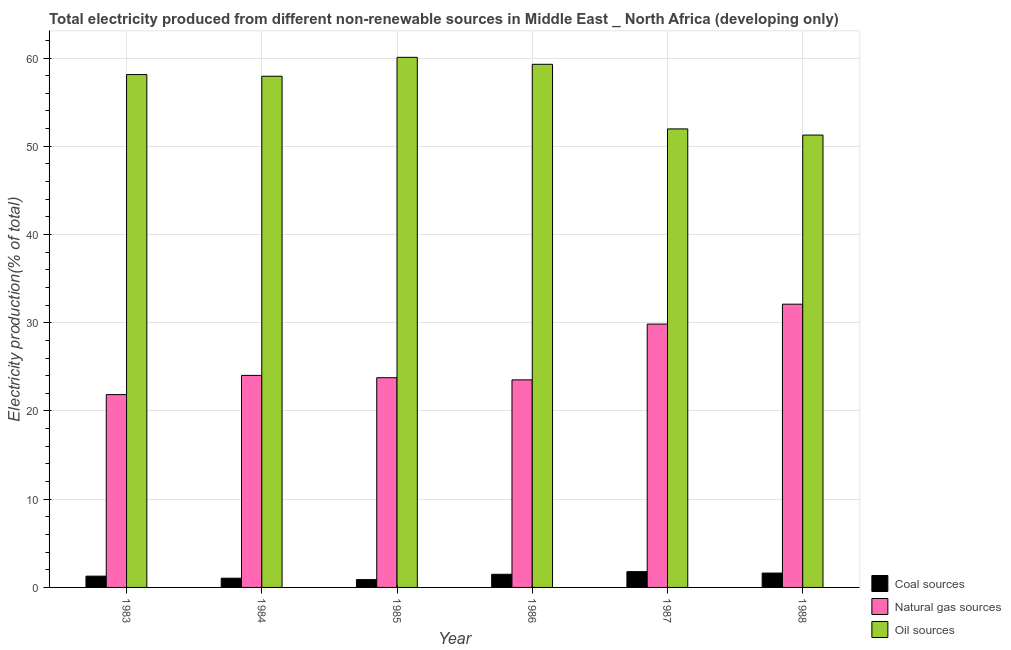How many different coloured bars are there?
Your response must be concise. 3. How many groups of bars are there?
Your answer should be compact. 6. What is the label of the 6th group of bars from the left?
Ensure brevity in your answer.  1988. In how many cases, is the number of bars for a given year not equal to the number of legend labels?
Provide a succinct answer. 0. What is the percentage of electricity produced by oil sources in 1987?
Your answer should be compact. 51.96. Across all years, what is the maximum percentage of electricity produced by oil sources?
Offer a very short reply. 60.08. Across all years, what is the minimum percentage of electricity produced by natural gas?
Your answer should be very brief. 21.85. In which year was the percentage of electricity produced by coal maximum?
Offer a terse response. 1987. In which year was the percentage of electricity produced by coal minimum?
Ensure brevity in your answer.  1985. What is the total percentage of electricity produced by oil sources in the graph?
Your answer should be very brief. 338.65. What is the difference between the percentage of electricity produced by oil sources in 1984 and that in 1986?
Provide a succinct answer. -1.35. What is the difference between the percentage of electricity produced by coal in 1988 and the percentage of electricity produced by oil sources in 1984?
Offer a very short reply. 0.58. What is the average percentage of electricity produced by coal per year?
Provide a succinct answer. 1.35. What is the ratio of the percentage of electricity produced by coal in 1983 to that in 1987?
Offer a terse response. 0.71. What is the difference between the highest and the second highest percentage of electricity produced by coal?
Your answer should be compact. 0.16. What is the difference between the highest and the lowest percentage of electricity produced by natural gas?
Provide a short and direct response. 10.25. In how many years, is the percentage of electricity produced by natural gas greater than the average percentage of electricity produced by natural gas taken over all years?
Keep it short and to the point. 2. Is the sum of the percentage of electricity produced by coal in 1983 and 1986 greater than the maximum percentage of electricity produced by natural gas across all years?
Offer a terse response. Yes. What does the 2nd bar from the left in 1988 represents?
Offer a very short reply. Natural gas sources. What does the 3rd bar from the right in 1985 represents?
Provide a short and direct response. Coal sources. Is it the case that in every year, the sum of the percentage of electricity produced by coal and percentage of electricity produced by natural gas is greater than the percentage of electricity produced by oil sources?
Provide a succinct answer. No. Are all the bars in the graph horizontal?
Your response must be concise. No. How many years are there in the graph?
Your answer should be compact. 6. What is the difference between two consecutive major ticks on the Y-axis?
Offer a terse response. 10. Does the graph contain any zero values?
Keep it short and to the point. No. Does the graph contain grids?
Offer a terse response. Yes. Where does the legend appear in the graph?
Your response must be concise. Bottom right. How many legend labels are there?
Keep it short and to the point. 3. What is the title of the graph?
Provide a short and direct response. Total electricity produced from different non-renewable sources in Middle East _ North Africa (developing only). What is the Electricity production(% of total) of Coal sources in 1983?
Your answer should be compact. 1.28. What is the Electricity production(% of total) of Natural gas sources in 1983?
Your response must be concise. 21.85. What is the Electricity production(% of total) of Oil sources in 1983?
Your response must be concise. 58.12. What is the Electricity production(% of total) of Coal sources in 1984?
Provide a short and direct response. 1.05. What is the Electricity production(% of total) of Natural gas sources in 1984?
Offer a terse response. 24.03. What is the Electricity production(% of total) of Oil sources in 1984?
Give a very brief answer. 57.93. What is the Electricity production(% of total) of Coal sources in 1985?
Offer a very short reply. 0.89. What is the Electricity production(% of total) of Natural gas sources in 1985?
Offer a terse response. 23.77. What is the Electricity production(% of total) of Oil sources in 1985?
Ensure brevity in your answer.  60.08. What is the Electricity production(% of total) in Coal sources in 1986?
Your answer should be compact. 1.49. What is the Electricity production(% of total) in Natural gas sources in 1986?
Keep it short and to the point. 23.52. What is the Electricity production(% of total) of Oil sources in 1986?
Your answer should be very brief. 59.29. What is the Electricity production(% of total) in Coal sources in 1987?
Your answer should be very brief. 1.79. What is the Electricity production(% of total) in Natural gas sources in 1987?
Your response must be concise. 29.85. What is the Electricity production(% of total) of Oil sources in 1987?
Provide a succinct answer. 51.96. What is the Electricity production(% of total) of Coal sources in 1988?
Offer a terse response. 1.63. What is the Electricity production(% of total) in Natural gas sources in 1988?
Offer a terse response. 32.1. What is the Electricity production(% of total) in Oil sources in 1988?
Ensure brevity in your answer.  51.27. Across all years, what is the maximum Electricity production(% of total) in Coal sources?
Keep it short and to the point. 1.79. Across all years, what is the maximum Electricity production(% of total) of Natural gas sources?
Your answer should be compact. 32.1. Across all years, what is the maximum Electricity production(% of total) in Oil sources?
Provide a succinct answer. 60.08. Across all years, what is the minimum Electricity production(% of total) of Coal sources?
Provide a succinct answer. 0.89. Across all years, what is the minimum Electricity production(% of total) in Natural gas sources?
Offer a very short reply. 21.85. Across all years, what is the minimum Electricity production(% of total) of Oil sources?
Keep it short and to the point. 51.27. What is the total Electricity production(% of total) of Coal sources in the graph?
Your answer should be very brief. 8.12. What is the total Electricity production(% of total) in Natural gas sources in the graph?
Your answer should be very brief. 155.12. What is the total Electricity production(% of total) in Oil sources in the graph?
Offer a very short reply. 338.65. What is the difference between the Electricity production(% of total) in Coal sources in 1983 and that in 1984?
Offer a very short reply. 0.23. What is the difference between the Electricity production(% of total) of Natural gas sources in 1983 and that in 1984?
Your response must be concise. -2.18. What is the difference between the Electricity production(% of total) in Oil sources in 1983 and that in 1984?
Offer a terse response. 0.19. What is the difference between the Electricity production(% of total) in Coal sources in 1983 and that in 1985?
Your answer should be very brief. 0.39. What is the difference between the Electricity production(% of total) in Natural gas sources in 1983 and that in 1985?
Ensure brevity in your answer.  -1.92. What is the difference between the Electricity production(% of total) in Oil sources in 1983 and that in 1985?
Offer a very short reply. -1.95. What is the difference between the Electricity production(% of total) of Coal sources in 1983 and that in 1986?
Keep it short and to the point. -0.21. What is the difference between the Electricity production(% of total) in Natural gas sources in 1983 and that in 1986?
Offer a very short reply. -1.67. What is the difference between the Electricity production(% of total) of Oil sources in 1983 and that in 1986?
Your response must be concise. -1.16. What is the difference between the Electricity production(% of total) of Coal sources in 1983 and that in 1987?
Give a very brief answer. -0.51. What is the difference between the Electricity production(% of total) in Natural gas sources in 1983 and that in 1987?
Provide a short and direct response. -7.99. What is the difference between the Electricity production(% of total) of Oil sources in 1983 and that in 1987?
Your response must be concise. 6.16. What is the difference between the Electricity production(% of total) in Coal sources in 1983 and that in 1988?
Give a very brief answer. -0.35. What is the difference between the Electricity production(% of total) of Natural gas sources in 1983 and that in 1988?
Make the answer very short. -10.25. What is the difference between the Electricity production(% of total) in Oil sources in 1983 and that in 1988?
Offer a very short reply. 6.86. What is the difference between the Electricity production(% of total) of Coal sources in 1984 and that in 1985?
Your answer should be very brief. 0.16. What is the difference between the Electricity production(% of total) of Natural gas sources in 1984 and that in 1985?
Ensure brevity in your answer.  0.26. What is the difference between the Electricity production(% of total) of Oil sources in 1984 and that in 1985?
Offer a terse response. -2.14. What is the difference between the Electricity production(% of total) in Coal sources in 1984 and that in 1986?
Your answer should be very brief. -0.44. What is the difference between the Electricity production(% of total) in Natural gas sources in 1984 and that in 1986?
Offer a terse response. 0.51. What is the difference between the Electricity production(% of total) of Oil sources in 1984 and that in 1986?
Provide a succinct answer. -1.35. What is the difference between the Electricity production(% of total) in Coal sources in 1984 and that in 1987?
Offer a very short reply. -0.74. What is the difference between the Electricity production(% of total) of Natural gas sources in 1984 and that in 1987?
Ensure brevity in your answer.  -5.82. What is the difference between the Electricity production(% of total) of Oil sources in 1984 and that in 1987?
Provide a short and direct response. 5.97. What is the difference between the Electricity production(% of total) in Coal sources in 1984 and that in 1988?
Keep it short and to the point. -0.58. What is the difference between the Electricity production(% of total) in Natural gas sources in 1984 and that in 1988?
Provide a succinct answer. -8.07. What is the difference between the Electricity production(% of total) of Oil sources in 1984 and that in 1988?
Your response must be concise. 6.67. What is the difference between the Electricity production(% of total) in Coal sources in 1985 and that in 1986?
Your response must be concise. -0.6. What is the difference between the Electricity production(% of total) of Natural gas sources in 1985 and that in 1986?
Your answer should be compact. 0.24. What is the difference between the Electricity production(% of total) of Oil sources in 1985 and that in 1986?
Give a very brief answer. 0.79. What is the difference between the Electricity production(% of total) of Coal sources in 1985 and that in 1987?
Make the answer very short. -0.9. What is the difference between the Electricity production(% of total) of Natural gas sources in 1985 and that in 1987?
Your answer should be very brief. -6.08. What is the difference between the Electricity production(% of total) in Oil sources in 1985 and that in 1987?
Your answer should be very brief. 8.11. What is the difference between the Electricity production(% of total) of Coal sources in 1985 and that in 1988?
Ensure brevity in your answer.  -0.74. What is the difference between the Electricity production(% of total) of Natural gas sources in 1985 and that in 1988?
Give a very brief answer. -8.33. What is the difference between the Electricity production(% of total) of Oil sources in 1985 and that in 1988?
Make the answer very short. 8.81. What is the difference between the Electricity production(% of total) of Coal sources in 1986 and that in 1987?
Offer a very short reply. -0.3. What is the difference between the Electricity production(% of total) of Natural gas sources in 1986 and that in 1987?
Your answer should be very brief. -6.32. What is the difference between the Electricity production(% of total) of Oil sources in 1986 and that in 1987?
Provide a succinct answer. 7.32. What is the difference between the Electricity production(% of total) of Coal sources in 1986 and that in 1988?
Your answer should be very brief. -0.14. What is the difference between the Electricity production(% of total) in Natural gas sources in 1986 and that in 1988?
Your answer should be compact. -8.58. What is the difference between the Electricity production(% of total) of Oil sources in 1986 and that in 1988?
Keep it short and to the point. 8.02. What is the difference between the Electricity production(% of total) in Coal sources in 1987 and that in 1988?
Make the answer very short. 0.16. What is the difference between the Electricity production(% of total) in Natural gas sources in 1987 and that in 1988?
Keep it short and to the point. -2.26. What is the difference between the Electricity production(% of total) in Oil sources in 1987 and that in 1988?
Keep it short and to the point. 0.7. What is the difference between the Electricity production(% of total) of Coal sources in 1983 and the Electricity production(% of total) of Natural gas sources in 1984?
Provide a succinct answer. -22.75. What is the difference between the Electricity production(% of total) of Coal sources in 1983 and the Electricity production(% of total) of Oil sources in 1984?
Ensure brevity in your answer.  -56.66. What is the difference between the Electricity production(% of total) in Natural gas sources in 1983 and the Electricity production(% of total) in Oil sources in 1984?
Offer a very short reply. -36.08. What is the difference between the Electricity production(% of total) in Coal sources in 1983 and the Electricity production(% of total) in Natural gas sources in 1985?
Keep it short and to the point. -22.49. What is the difference between the Electricity production(% of total) of Coal sources in 1983 and the Electricity production(% of total) of Oil sources in 1985?
Your answer should be very brief. -58.8. What is the difference between the Electricity production(% of total) in Natural gas sources in 1983 and the Electricity production(% of total) in Oil sources in 1985?
Keep it short and to the point. -38.22. What is the difference between the Electricity production(% of total) in Coal sources in 1983 and the Electricity production(% of total) in Natural gas sources in 1986?
Your answer should be very brief. -22.25. What is the difference between the Electricity production(% of total) in Coal sources in 1983 and the Electricity production(% of total) in Oil sources in 1986?
Give a very brief answer. -58.01. What is the difference between the Electricity production(% of total) of Natural gas sources in 1983 and the Electricity production(% of total) of Oil sources in 1986?
Your answer should be compact. -37.43. What is the difference between the Electricity production(% of total) of Coal sources in 1983 and the Electricity production(% of total) of Natural gas sources in 1987?
Give a very brief answer. -28.57. What is the difference between the Electricity production(% of total) of Coal sources in 1983 and the Electricity production(% of total) of Oil sources in 1987?
Offer a very short reply. -50.69. What is the difference between the Electricity production(% of total) in Natural gas sources in 1983 and the Electricity production(% of total) in Oil sources in 1987?
Give a very brief answer. -30.11. What is the difference between the Electricity production(% of total) of Coal sources in 1983 and the Electricity production(% of total) of Natural gas sources in 1988?
Keep it short and to the point. -30.82. What is the difference between the Electricity production(% of total) of Coal sources in 1983 and the Electricity production(% of total) of Oil sources in 1988?
Provide a short and direct response. -49.99. What is the difference between the Electricity production(% of total) in Natural gas sources in 1983 and the Electricity production(% of total) in Oil sources in 1988?
Keep it short and to the point. -29.41. What is the difference between the Electricity production(% of total) of Coal sources in 1984 and the Electricity production(% of total) of Natural gas sources in 1985?
Give a very brief answer. -22.72. What is the difference between the Electricity production(% of total) of Coal sources in 1984 and the Electricity production(% of total) of Oil sources in 1985?
Provide a short and direct response. -59.03. What is the difference between the Electricity production(% of total) in Natural gas sources in 1984 and the Electricity production(% of total) in Oil sources in 1985?
Your response must be concise. -36.05. What is the difference between the Electricity production(% of total) in Coal sources in 1984 and the Electricity production(% of total) in Natural gas sources in 1986?
Keep it short and to the point. -22.48. What is the difference between the Electricity production(% of total) of Coal sources in 1984 and the Electricity production(% of total) of Oil sources in 1986?
Offer a very short reply. -58.24. What is the difference between the Electricity production(% of total) of Natural gas sources in 1984 and the Electricity production(% of total) of Oil sources in 1986?
Make the answer very short. -35.26. What is the difference between the Electricity production(% of total) of Coal sources in 1984 and the Electricity production(% of total) of Natural gas sources in 1987?
Your response must be concise. -28.8. What is the difference between the Electricity production(% of total) of Coal sources in 1984 and the Electricity production(% of total) of Oil sources in 1987?
Offer a terse response. -50.92. What is the difference between the Electricity production(% of total) of Natural gas sources in 1984 and the Electricity production(% of total) of Oil sources in 1987?
Keep it short and to the point. -27.93. What is the difference between the Electricity production(% of total) of Coal sources in 1984 and the Electricity production(% of total) of Natural gas sources in 1988?
Your response must be concise. -31.05. What is the difference between the Electricity production(% of total) in Coal sources in 1984 and the Electricity production(% of total) in Oil sources in 1988?
Make the answer very short. -50.22. What is the difference between the Electricity production(% of total) in Natural gas sources in 1984 and the Electricity production(% of total) in Oil sources in 1988?
Keep it short and to the point. -27.24. What is the difference between the Electricity production(% of total) of Coal sources in 1985 and the Electricity production(% of total) of Natural gas sources in 1986?
Offer a very short reply. -22.64. What is the difference between the Electricity production(% of total) in Coal sources in 1985 and the Electricity production(% of total) in Oil sources in 1986?
Provide a succinct answer. -58.4. What is the difference between the Electricity production(% of total) of Natural gas sources in 1985 and the Electricity production(% of total) of Oil sources in 1986?
Your answer should be compact. -35.52. What is the difference between the Electricity production(% of total) of Coal sources in 1985 and the Electricity production(% of total) of Natural gas sources in 1987?
Keep it short and to the point. -28.96. What is the difference between the Electricity production(% of total) of Coal sources in 1985 and the Electricity production(% of total) of Oil sources in 1987?
Your answer should be very brief. -51.08. What is the difference between the Electricity production(% of total) of Natural gas sources in 1985 and the Electricity production(% of total) of Oil sources in 1987?
Ensure brevity in your answer.  -28.2. What is the difference between the Electricity production(% of total) in Coal sources in 1985 and the Electricity production(% of total) in Natural gas sources in 1988?
Your answer should be compact. -31.21. What is the difference between the Electricity production(% of total) of Coal sources in 1985 and the Electricity production(% of total) of Oil sources in 1988?
Provide a short and direct response. -50.38. What is the difference between the Electricity production(% of total) in Natural gas sources in 1985 and the Electricity production(% of total) in Oil sources in 1988?
Make the answer very short. -27.5. What is the difference between the Electricity production(% of total) in Coal sources in 1986 and the Electricity production(% of total) in Natural gas sources in 1987?
Keep it short and to the point. -28.35. What is the difference between the Electricity production(% of total) of Coal sources in 1986 and the Electricity production(% of total) of Oil sources in 1987?
Give a very brief answer. -50.47. What is the difference between the Electricity production(% of total) of Natural gas sources in 1986 and the Electricity production(% of total) of Oil sources in 1987?
Offer a very short reply. -28.44. What is the difference between the Electricity production(% of total) in Coal sources in 1986 and the Electricity production(% of total) in Natural gas sources in 1988?
Give a very brief answer. -30.61. What is the difference between the Electricity production(% of total) in Coal sources in 1986 and the Electricity production(% of total) in Oil sources in 1988?
Keep it short and to the point. -49.78. What is the difference between the Electricity production(% of total) in Natural gas sources in 1986 and the Electricity production(% of total) in Oil sources in 1988?
Offer a terse response. -27.74. What is the difference between the Electricity production(% of total) in Coal sources in 1987 and the Electricity production(% of total) in Natural gas sources in 1988?
Your response must be concise. -30.31. What is the difference between the Electricity production(% of total) of Coal sources in 1987 and the Electricity production(% of total) of Oil sources in 1988?
Make the answer very short. -49.48. What is the difference between the Electricity production(% of total) in Natural gas sources in 1987 and the Electricity production(% of total) in Oil sources in 1988?
Make the answer very short. -21.42. What is the average Electricity production(% of total) in Coal sources per year?
Your answer should be very brief. 1.35. What is the average Electricity production(% of total) in Natural gas sources per year?
Your answer should be very brief. 25.85. What is the average Electricity production(% of total) of Oil sources per year?
Offer a very short reply. 56.44. In the year 1983, what is the difference between the Electricity production(% of total) of Coal sources and Electricity production(% of total) of Natural gas sources?
Make the answer very short. -20.58. In the year 1983, what is the difference between the Electricity production(% of total) in Coal sources and Electricity production(% of total) in Oil sources?
Provide a succinct answer. -56.85. In the year 1983, what is the difference between the Electricity production(% of total) in Natural gas sources and Electricity production(% of total) in Oil sources?
Your response must be concise. -36.27. In the year 1984, what is the difference between the Electricity production(% of total) in Coal sources and Electricity production(% of total) in Natural gas sources?
Your answer should be compact. -22.98. In the year 1984, what is the difference between the Electricity production(% of total) of Coal sources and Electricity production(% of total) of Oil sources?
Your answer should be very brief. -56.89. In the year 1984, what is the difference between the Electricity production(% of total) in Natural gas sources and Electricity production(% of total) in Oil sources?
Your answer should be very brief. -33.9. In the year 1985, what is the difference between the Electricity production(% of total) in Coal sources and Electricity production(% of total) in Natural gas sources?
Make the answer very short. -22.88. In the year 1985, what is the difference between the Electricity production(% of total) of Coal sources and Electricity production(% of total) of Oil sources?
Your answer should be very brief. -59.19. In the year 1985, what is the difference between the Electricity production(% of total) of Natural gas sources and Electricity production(% of total) of Oil sources?
Offer a very short reply. -36.31. In the year 1986, what is the difference between the Electricity production(% of total) in Coal sources and Electricity production(% of total) in Natural gas sources?
Offer a terse response. -22.03. In the year 1986, what is the difference between the Electricity production(% of total) of Coal sources and Electricity production(% of total) of Oil sources?
Your response must be concise. -57.8. In the year 1986, what is the difference between the Electricity production(% of total) of Natural gas sources and Electricity production(% of total) of Oil sources?
Offer a terse response. -35.76. In the year 1987, what is the difference between the Electricity production(% of total) of Coal sources and Electricity production(% of total) of Natural gas sources?
Provide a short and direct response. -28.06. In the year 1987, what is the difference between the Electricity production(% of total) in Coal sources and Electricity production(% of total) in Oil sources?
Offer a very short reply. -50.17. In the year 1987, what is the difference between the Electricity production(% of total) in Natural gas sources and Electricity production(% of total) in Oil sources?
Ensure brevity in your answer.  -22.12. In the year 1988, what is the difference between the Electricity production(% of total) of Coal sources and Electricity production(% of total) of Natural gas sources?
Your answer should be very brief. -30.47. In the year 1988, what is the difference between the Electricity production(% of total) of Coal sources and Electricity production(% of total) of Oil sources?
Your answer should be compact. -49.64. In the year 1988, what is the difference between the Electricity production(% of total) of Natural gas sources and Electricity production(% of total) of Oil sources?
Your response must be concise. -19.17. What is the ratio of the Electricity production(% of total) of Coal sources in 1983 to that in 1984?
Offer a terse response. 1.22. What is the ratio of the Electricity production(% of total) of Natural gas sources in 1983 to that in 1984?
Make the answer very short. 0.91. What is the ratio of the Electricity production(% of total) of Coal sources in 1983 to that in 1985?
Offer a very short reply. 1.44. What is the ratio of the Electricity production(% of total) in Natural gas sources in 1983 to that in 1985?
Your answer should be compact. 0.92. What is the ratio of the Electricity production(% of total) of Oil sources in 1983 to that in 1985?
Your answer should be very brief. 0.97. What is the ratio of the Electricity production(% of total) of Coal sources in 1983 to that in 1986?
Keep it short and to the point. 0.86. What is the ratio of the Electricity production(% of total) of Natural gas sources in 1983 to that in 1986?
Your response must be concise. 0.93. What is the ratio of the Electricity production(% of total) of Oil sources in 1983 to that in 1986?
Give a very brief answer. 0.98. What is the ratio of the Electricity production(% of total) of Coal sources in 1983 to that in 1987?
Give a very brief answer. 0.71. What is the ratio of the Electricity production(% of total) in Natural gas sources in 1983 to that in 1987?
Your response must be concise. 0.73. What is the ratio of the Electricity production(% of total) of Oil sources in 1983 to that in 1987?
Offer a terse response. 1.12. What is the ratio of the Electricity production(% of total) of Coal sources in 1983 to that in 1988?
Offer a very short reply. 0.78. What is the ratio of the Electricity production(% of total) in Natural gas sources in 1983 to that in 1988?
Your response must be concise. 0.68. What is the ratio of the Electricity production(% of total) of Oil sources in 1983 to that in 1988?
Your answer should be very brief. 1.13. What is the ratio of the Electricity production(% of total) of Coal sources in 1984 to that in 1985?
Make the answer very short. 1.18. What is the ratio of the Electricity production(% of total) of Oil sources in 1984 to that in 1985?
Give a very brief answer. 0.96. What is the ratio of the Electricity production(% of total) in Coal sources in 1984 to that in 1986?
Keep it short and to the point. 0.7. What is the ratio of the Electricity production(% of total) of Natural gas sources in 1984 to that in 1986?
Your answer should be compact. 1.02. What is the ratio of the Electricity production(% of total) of Oil sources in 1984 to that in 1986?
Your response must be concise. 0.98. What is the ratio of the Electricity production(% of total) in Coal sources in 1984 to that in 1987?
Provide a short and direct response. 0.58. What is the ratio of the Electricity production(% of total) in Natural gas sources in 1984 to that in 1987?
Make the answer very short. 0.81. What is the ratio of the Electricity production(% of total) of Oil sources in 1984 to that in 1987?
Your answer should be very brief. 1.11. What is the ratio of the Electricity production(% of total) of Coal sources in 1984 to that in 1988?
Give a very brief answer. 0.64. What is the ratio of the Electricity production(% of total) in Natural gas sources in 1984 to that in 1988?
Provide a succinct answer. 0.75. What is the ratio of the Electricity production(% of total) of Oil sources in 1984 to that in 1988?
Ensure brevity in your answer.  1.13. What is the ratio of the Electricity production(% of total) of Coal sources in 1985 to that in 1986?
Give a very brief answer. 0.59. What is the ratio of the Electricity production(% of total) in Natural gas sources in 1985 to that in 1986?
Ensure brevity in your answer.  1.01. What is the ratio of the Electricity production(% of total) in Oil sources in 1985 to that in 1986?
Your answer should be very brief. 1.01. What is the ratio of the Electricity production(% of total) in Coal sources in 1985 to that in 1987?
Offer a very short reply. 0.5. What is the ratio of the Electricity production(% of total) of Natural gas sources in 1985 to that in 1987?
Make the answer very short. 0.8. What is the ratio of the Electricity production(% of total) in Oil sources in 1985 to that in 1987?
Offer a very short reply. 1.16. What is the ratio of the Electricity production(% of total) in Coal sources in 1985 to that in 1988?
Your answer should be very brief. 0.54. What is the ratio of the Electricity production(% of total) in Natural gas sources in 1985 to that in 1988?
Give a very brief answer. 0.74. What is the ratio of the Electricity production(% of total) of Oil sources in 1985 to that in 1988?
Offer a very short reply. 1.17. What is the ratio of the Electricity production(% of total) of Coal sources in 1986 to that in 1987?
Your response must be concise. 0.83. What is the ratio of the Electricity production(% of total) in Natural gas sources in 1986 to that in 1987?
Ensure brevity in your answer.  0.79. What is the ratio of the Electricity production(% of total) of Oil sources in 1986 to that in 1987?
Keep it short and to the point. 1.14. What is the ratio of the Electricity production(% of total) of Coal sources in 1986 to that in 1988?
Keep it short and to the point. 0.92. What is the ratio of the Electricity production(% of total) of Natural gas sources in 1986 to that in 1988?
Your answer should be compact. 0.73. What is the ratio of the Electricity production(% of total) of Oil sources in 1986 to that in 1988?
Make the answer very short. 1.16. What is the ratio of the Electricity production(% of total) in Coal sources in 1987 to that in 1988?
Provide a short and direct response. 1.1. What is the ratio of the Electricity production(% of total) in Natural gas sources in 1987 to that in 1988?
Make the answer very short. 0.93. What is the ratio of the Electricity production(% of total) in Oil sources in 1987 to that in 1988?
Offer a terse response. 1.01. What is the difference between the highest and the second highest Electricity production(% of total) in Coal sources?
Your answer should be compact. 0.16. What is the difference between the highest and the second highest Electricity production(% of total) of Natural gas sources?
Offer a terse response. 2.26. What is the difference between the highest and the second highest Electricity production(% of total) in Oil sources?
Your answer should be compact. 0.79. What is the difference between the highest and the lowest Electricity production(% of total) of Coal sources?
Provide a short and direct response. 0.9. What is the difference between the highest and the lowest Electricity production(% of total) of Natural gas sources?
Ensure brevity in your answer.  10.25. What is the difference between the highest and the lowest Electricity production(% of total) of Oil sources?
Your answer should be very brief. 8.81. 